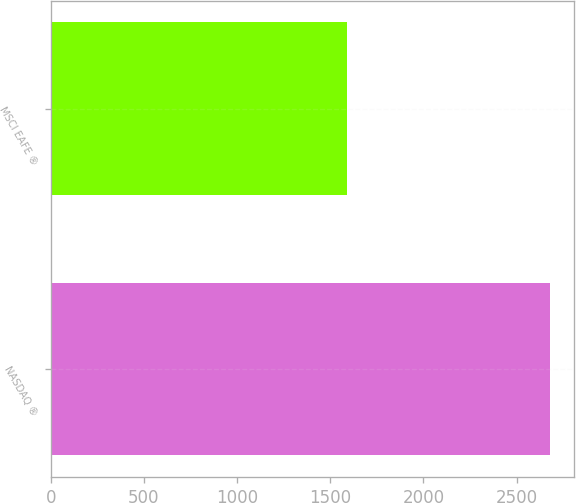Convert chart. <chart><loc_0><loc_0><loc_500><loc_500><bar_chart><fcel>NASDAQ ®<fcel>MSCI EAFE ®<nl><fcel>2677<fcel>1590<nl></chart> 